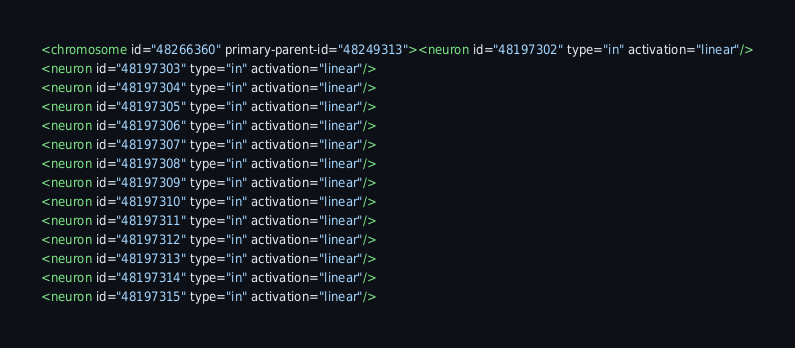<code> <loc_0><loc_0><loc_500><loc_500><_XML_><chromosome id="48266360" primary-parent-id="48249313"><neuron id="48197302" type="in" activation="linear"/>
<neuron id="48197303" type="in" activation="linear"/>
<neuron id="48197304" type="in" activation="linear"/>
<neuron id="48197305" type="in" activation="linear"/>
<neuron id="48197306" type="in" activation="linear"/>
<neuron id="48197307" type="in" activation="linear"/>
<neuron id="48197308" type="in" activation="linear"/>
<neuron id="48197309" type="in" activation="linear"/>
<neuron id="48197310" type="in" activation="linear"/>
<neuron id="48197311" type="in" activation="linear"/>
<neuron id="48197312" type="in" activation="linear"/>
<neuron id="48197313" type="in" activation="linear"/>
<neuron id="48197314" type="in" activation="linear"/>
<neuron id="48197315" type="in" activation="linear"/></code> 